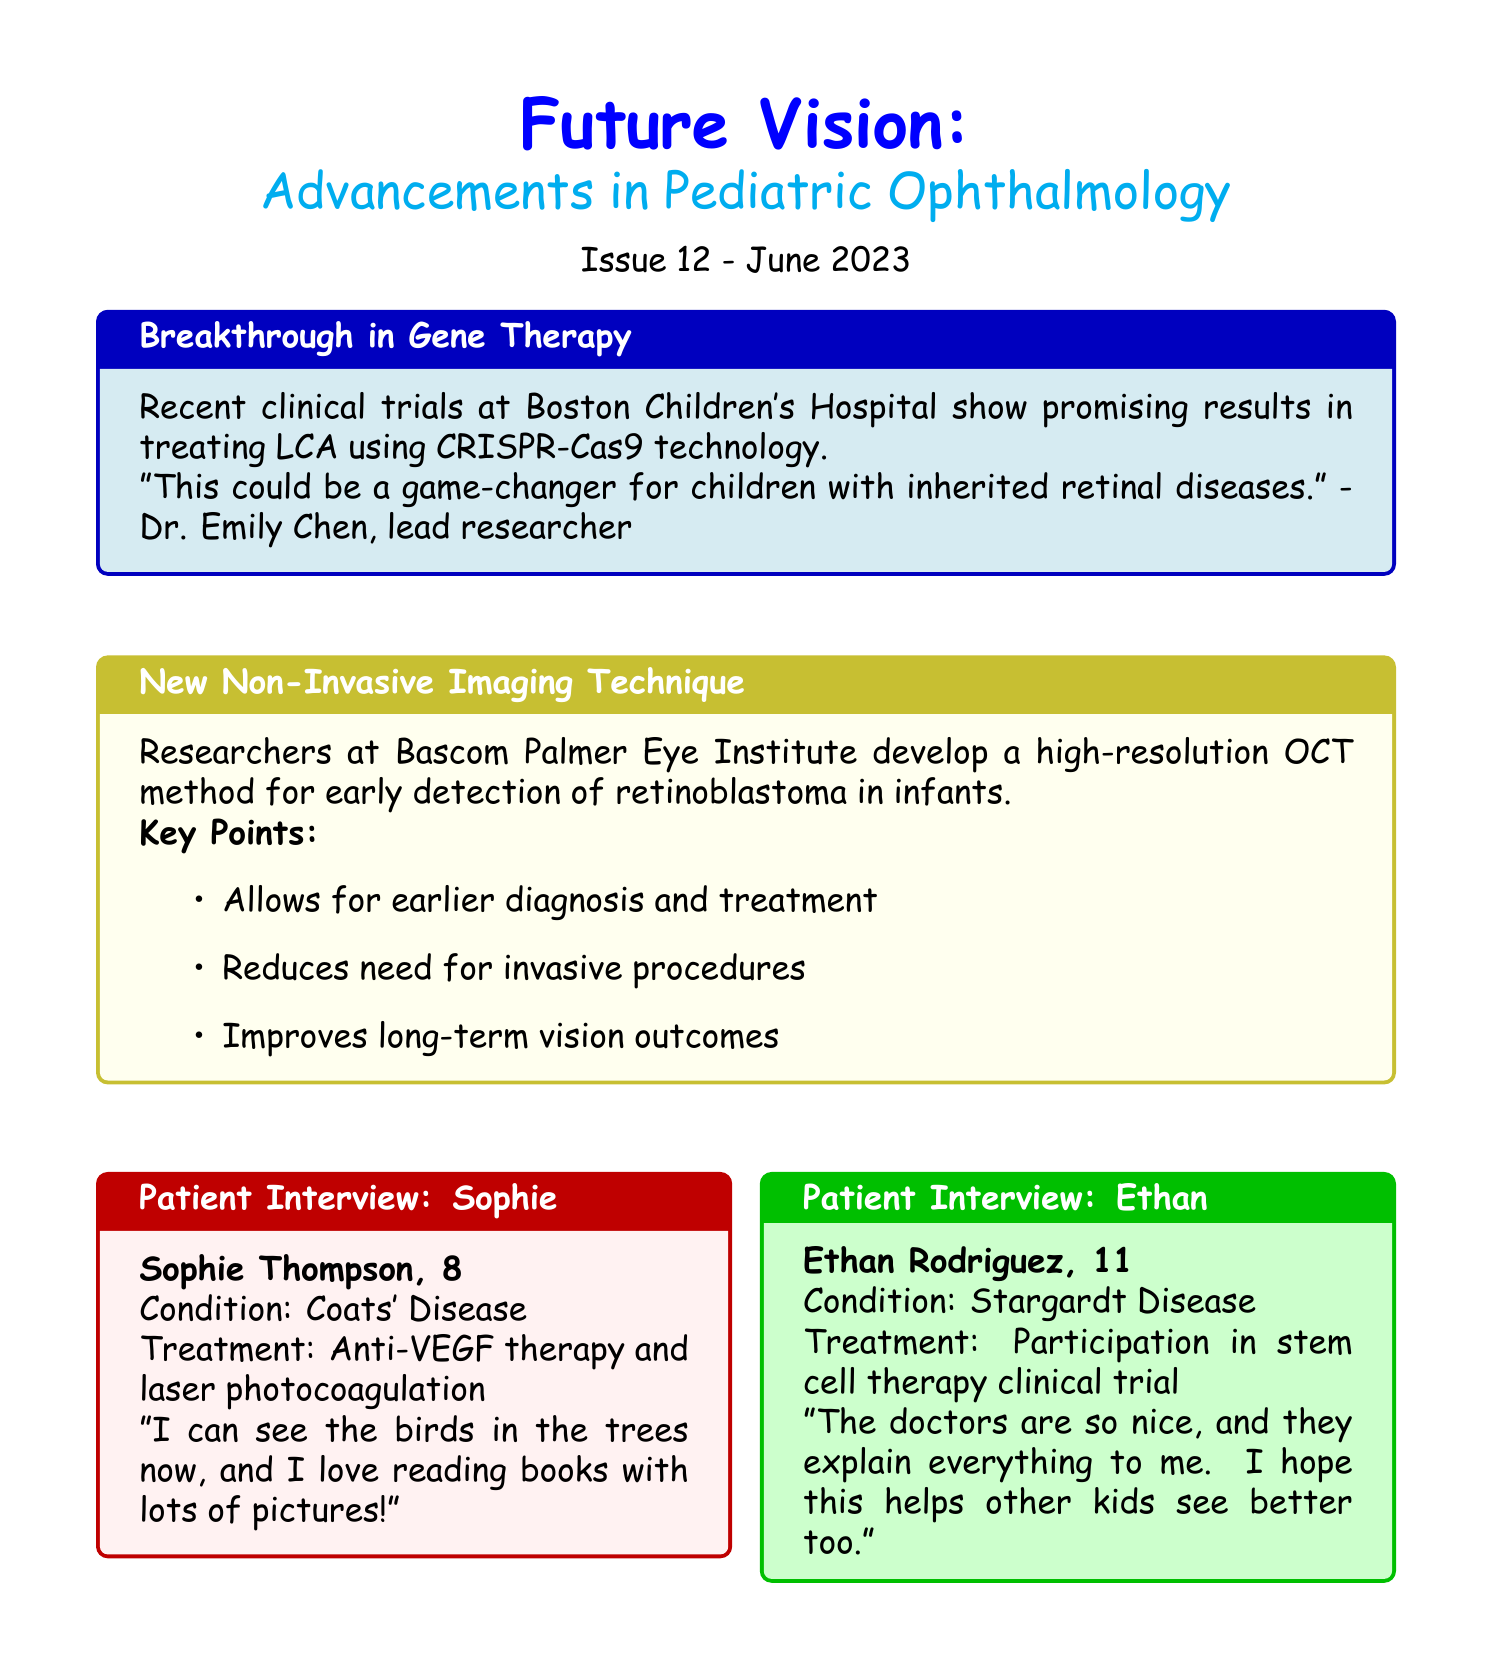What is the title of the newsletter? The title of the newsletter is provided at the beginning of the document.
Answer: Future Vision: Advancements in Pediatric Ophthalmology Who is the lead researcher mentioned in the gene therapy article? The lead researcher is quoted in the article discussing breakthroughs in gene therapy for Leber Congenital Amaurosis.
Answer: Dr. Emily Chen What is the age of Sophie Thompson? Sophie Thompson's age is stated in her interview section.
Answer: 8 What disease is Ethan Rodriguez participating in a clinical trial for? Ethan's condition is mentioned directly in his interview.
Answer: Stargardt Disease When is the International Pediatric Ophthalmology and Strabismus Conference taking place? The date of the upcoming event is clearly outlined in the event section.
Answer: September 15-17, 2023 What technology is spotlighted in the newsletter? The technology spotlight section introduces a specific advancement in retinal disease detection.
Answer: AI-Powered Retinal Disease Detection What is one of the key points about the new non-invasive imaging technique? Key points about the new technique are listed in its section, highlighting its benefits.
Answer: Reduces need for invasive procedures What is the name of the featured doctor in the career spotlight? The featured doctor's name is clearly mentioned in the career spotlight section.
Answer: Dr. Sarah Patel 